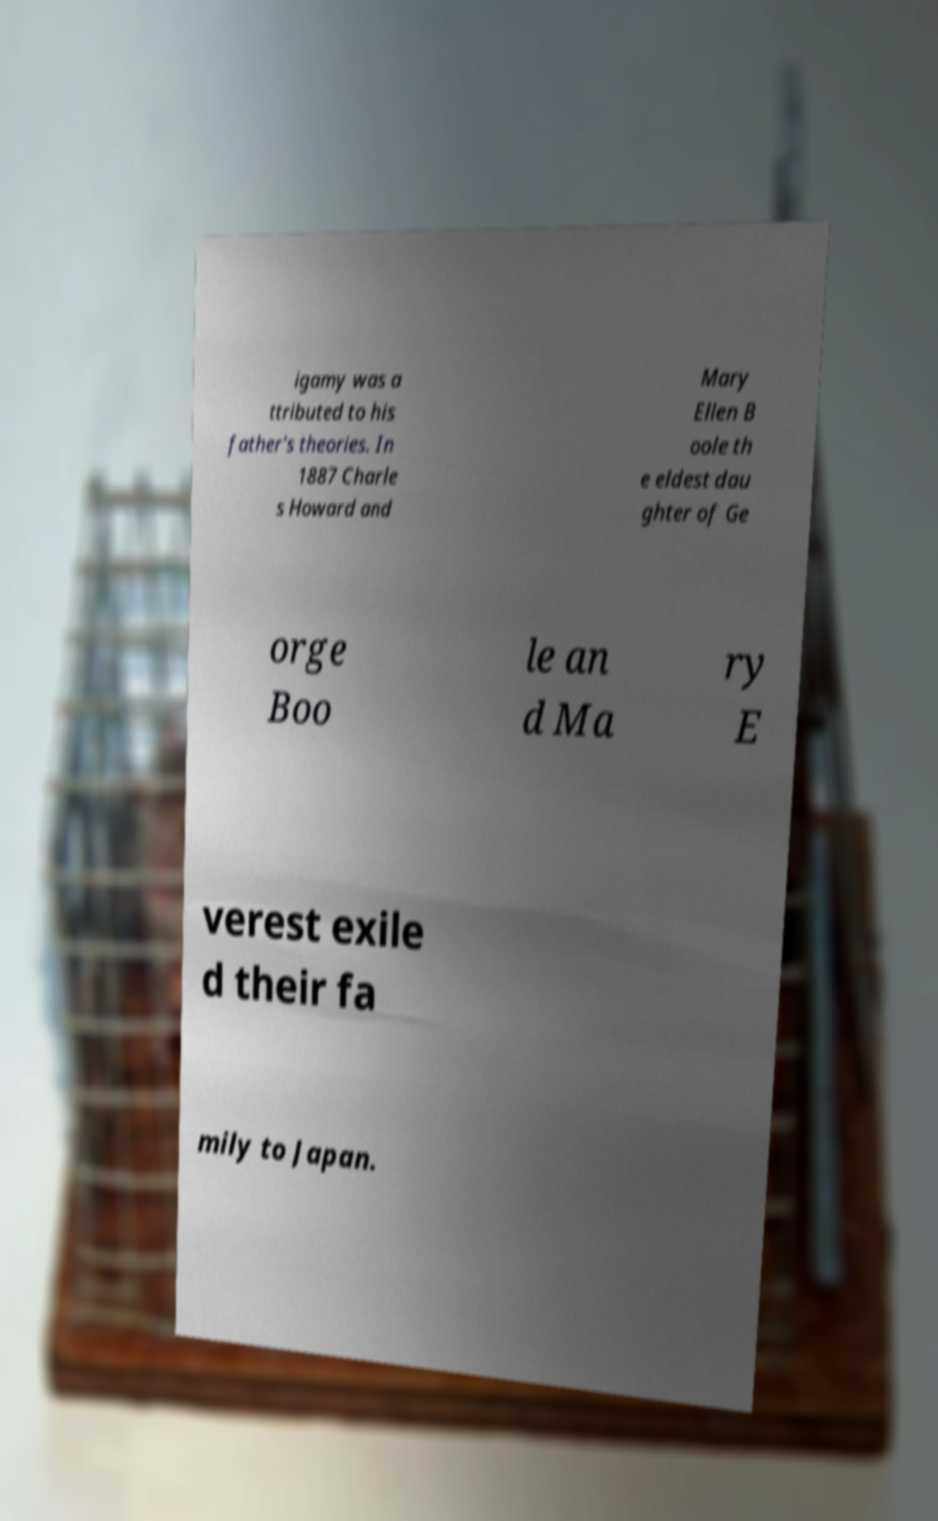Could you extract and type out the text from this image? igamy was a ttributed to his father's theories. In 1887 Charle s Howard and Mary Ellen B oole th e eldest dau ghter of Ge orge Boo le an d Ma ry E verest exile d their fa mily to Japan. 